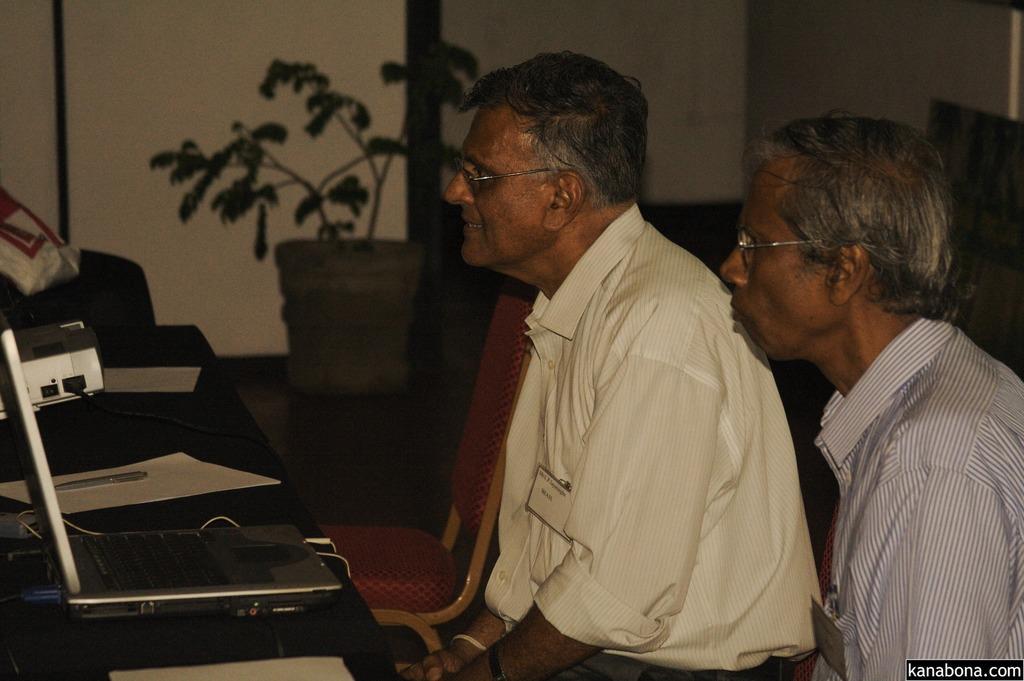Could you give a brief overview of what you see in this image? In the center of the image we can see two persons are sitting and they are wearing glasses. In front of them, there is a platform. On the platform, we can see a laptop, pen, papers and some objects. At the bottom right side of the image, we can see some text. In the background, there is a wall, chair, pot with a plant and a few other objects. 